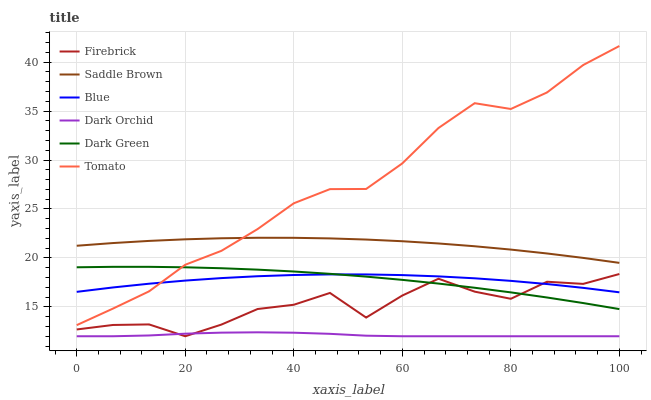Does Dark Orchid have the minimum area under the curve?
Answer yes or no. Yes. Does Tomato have the maximum area under the curve?
Answer yes or no. Yes. Does Firebrick have the minimum area under the curve?
Answer yes or no. No. Does Firebrick have the maximum area under the curve?
Answer yes or no. No. Is Dark Green the smoothest?
Answer yes or no. Yes. Is Firebrick the roughest?
Answer yes or no. Yes. Is Tomato the smoothest?
Answer yes or no. No. Is Tomato the roughest?
Answer yes or no. No. Does Firebrick have the lowest value?
Answer yes or no. Yes. Does Tomato have the lowest value?
Answer yes or no. No. Does Tomato have the highest value?
Answer yes or no. Yes. Does Firebrick have the highest value?
Answer yes or no. No. Is Dark Orchid less than Saddle Brown?
Answer yes or no. Yes. Is Blue greater than Dark Orchid?
Answer yes or no. Yes. Does Dark Orchid intersect Firebrick?
Answer yes or no. Yes. Is Dark Orchid less than Firebrick?
Answer yes or no. No. Is Dark Orchid greater than Firebrick?
Answer yes or no. No. Does Dark Orchid intersect Saddle Brown?
Answer yes or no. No. 